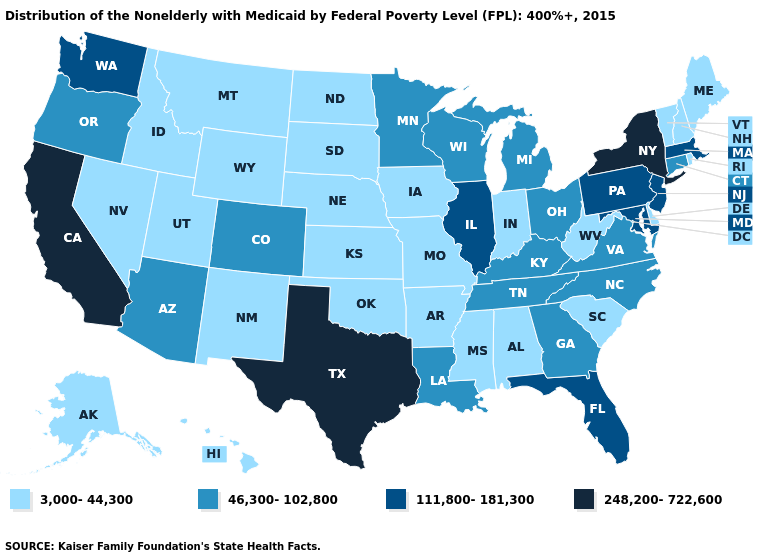Name the states that have a value in the range 111,800-181,300?
Short answer required. Florida, Illinois, Maryland, Massachusetts, New Jersey, Pennsylvania, Washington. Does Colorado have the lowest value in the USA?
Be succinct. No. What is the lowest value in the USA?
Give a very brief answer. 3,000-44,300. How many symbols are there in the legend?
Quick response, please. 4. What is the value of Iowa?
Write a very short answer. 3,000-44,300. Which states have the lowest value in the MidWest?
Be succinct. Indiana, Iowa, Kansas, Missouri, Nebraska, North Dakota, South Dakota. Which states hav the highest value in the West?
Be succinct. California. What is the value of South Carolina?
Give a very brief answer. 3,000-44,300. Which states hav the highest value in the West?
Keep it brief. California. Which states have the highest value in the USA?
Quick response, please. California, New York, Texas. What is the value of Rhode Island?
Write a very short answer. 3,000-44,300. Does the first symbol in the legend represent the smallest category?
Keep it brief. Yes. Which states have the lowest value in the USA?
Concise answer only. Alabama, Alaska, Arkansas, Delaware, Hawaii, Idaho, Indiana, Iowa, Kansas, Maine, Mississippi, Missouri, Montana, Nebraska, Nevada, New Hampshire, New Mexico, North Dakota, Oklahoma, Rhode Island, South Carolina, South Dakota, Utah, Vermont, West Virginia, Wyoming. Name the states that have a value in the range 3,000-44,300?
Give a very brief answer. Alabama, Alaska, Arkansas, Delaware, Hawaii, Idaho, Indiana, Iowa, Kansas, Maine, Mississippi, Missouri, Montana, Nebraska, Nevada, New Hampshire, New Mexico, North Dakota, Oklahoma, Rhode Island, South Carolina, South Dakota, Utah, Vermont, West Virginia, Wyoming. Which states have the lowest value in the USA?
Give a very brief answer. Alabama, Alaska, Arkansas, Delaware, Hawaii, Idaho, Indiana, Iowa, Kansas, Maine, Mississippi, Missouri, Montana, Nebraska, Nevada, New Hampshire, New Mexico, North Dakota, Oklahoma, Rhode Island, South Carolina, South Dakota, Utah, Vermont, West Virginia, Wyoming. 